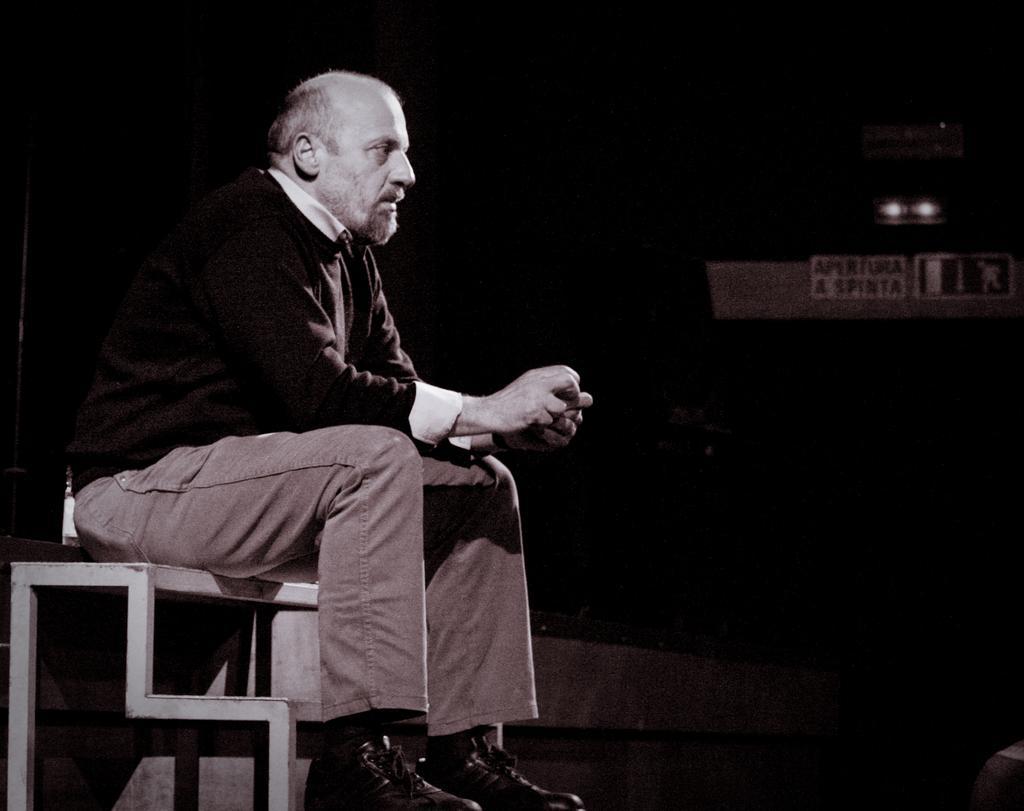Could you give a brief overview of what you see in this image? In this picture we can see a person sitting on the table. 